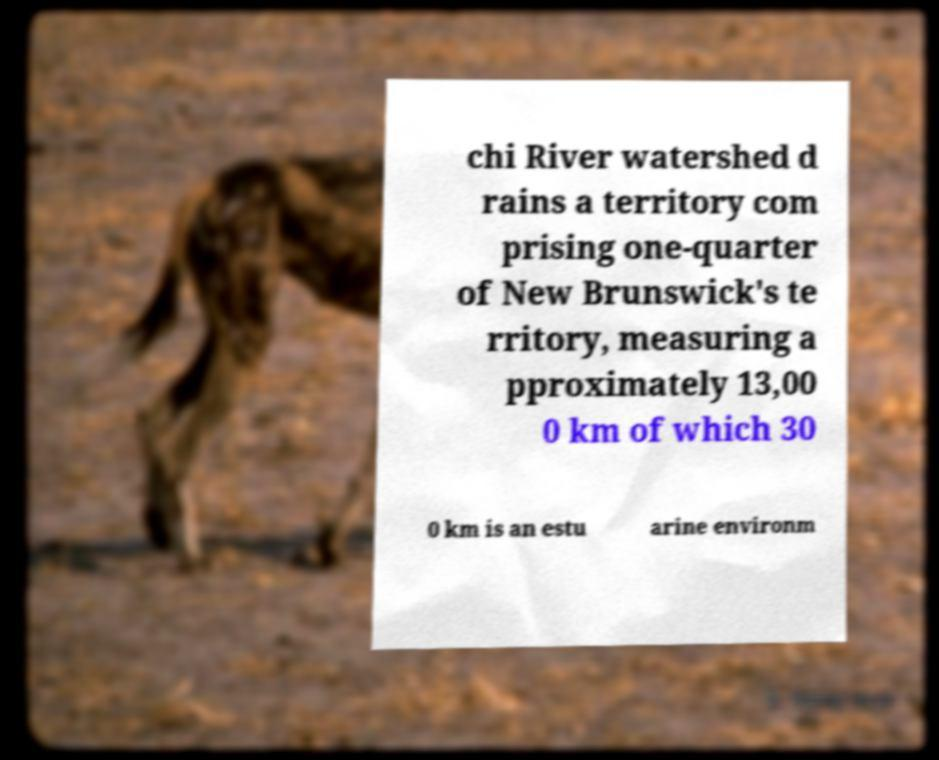I need the written content from this picture converted into text. Can you do that? chi River watershed d rains a territory com prising one-quarter of New Brunswick's te rritory, measuring a pproximately 13,00 0 km of which 30 0 km is an estu arine environm 